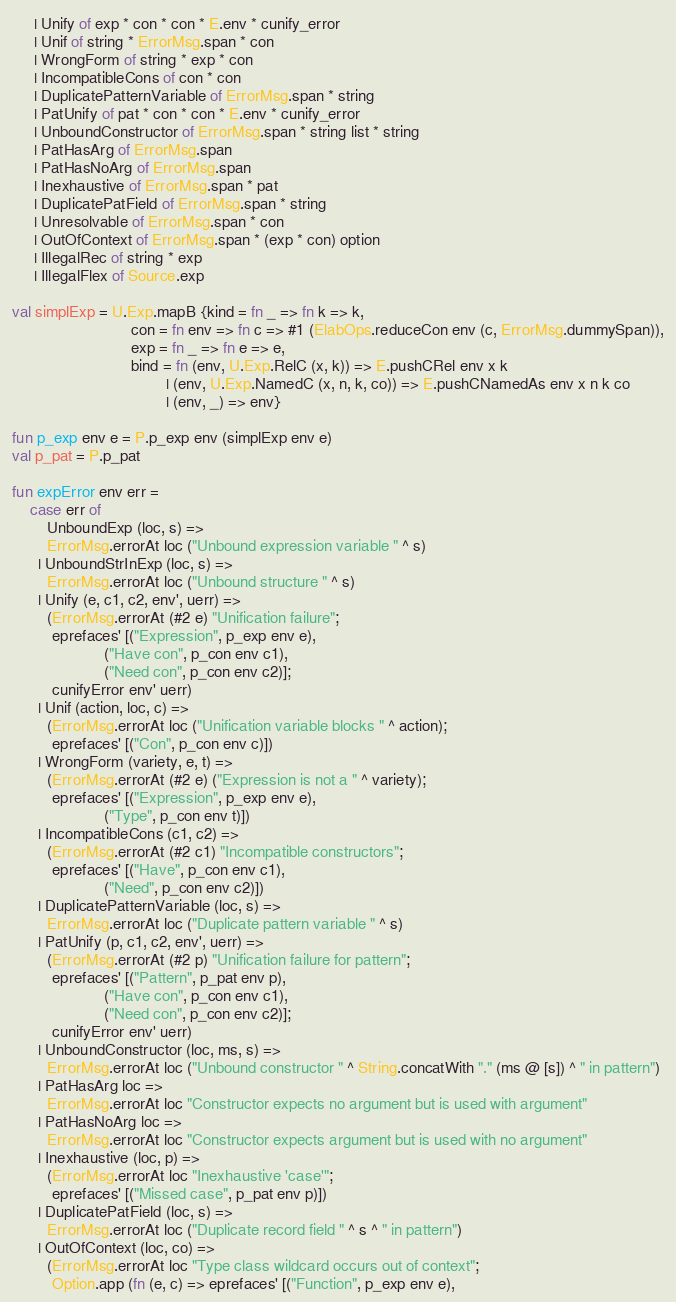<code> <loc_0><loc_0><loc_500><loc_500><_SML_>     | Unify of exp * con * con * E.env * cunify_error
     | Unif of string * ErrorMsg.span * con
     | WrongForm of string * exp * con
     | IncompatibleCons of con * con
     | DuplicatePatternVariable of ErrorMsg.span * string
     | PatUnify of pat * con * con * E.env * cunify_error
     | UnboundConstructor of ErrorMsg.span * string list * string
     | PatHasArg of ErrorMsg.span
     | PatHasNoArg of ErrorMsg.span
     | Inexhaustive of ErrorMsg.span * pat
     | DuplicatePatField of ErrorMsg.span * string
     | Unresolvable of ErrorMsg.span * con
     | OutOfContext of ErrorMsg.span * (exp * con) option
     | IllegalRec of string * exp
     | IllegalFlex of Source.exp

val simplExp = U.Exp.mapB {kind = fn _ => fn k => k,
                           con = fn env => fn c => #1 (ElabOps.reduceCon env (c, ErrorMsg.dummySpan)),
                           exp = fn _ => fn e => e,
                           bind = fn (env, U.Exp.RelC (x, k)) => E.pushCRel env x k
                                   | (env, U.Exp.NamedC (x, n, k, co)) => E.pushCNamedAs env x n k co
                                   | (env, _) => env}

fun p_exp env e = P.p_exp env (simplExp env e)
val p_pat = P.p_pat

fun expError env err =
    case err of
        UnboundExp (loc, s) =>
        ErrorMsg.errorAt loc ("Unbound expression variable " ^ s)
      | UnboundStrInExp (loc, s) =>
        ErrorMsg.errorAt loc ("Unbound structure " ^ s)
      | Unify (e, c1, c2, env', uerr) =>
        (ErrorMsg.errorAt (#2 e) "Unification failure";
         eprefaces' [("Expression", p_exp env e),
                     ("Have con", p_con env c1),
                     ("Need con", p_con env c2)];
         cunifyError env' uerr)
      | Unif (action, loc, c) =>
        (ErrorMsg.errorAt loc ("Unification variable blocks " ^ action);
         eprefaces' [("Con", p_con env c)])
      | WrongForm (variety, e, t) =>
        (ErrorMsg.errorAt (#2 e) ("Expression is not a " ^ variety);
         eprefaces' [("Expression", p_exp env e),
                     ("Type", p_con env t)])
      | IncompatibleCons (c1, c2) =>
        (ErrorMsg.errorAt (#2 c1) "Incompatible constructors";
         eprefaces' [("Have", p_con env c1),
                     ("Need", p_con env c2)])
      | DuplicatePatternVariable (loc, s) =>
        ErrorMsg.errorAt loc ("Duplicate pattern variable " ^ s)
      | PatUnify (p, c1, c2, env', uerr) =>
        (ErrorMsg.errorAt (#2 p) "Unification failure for pattern";
         eprefaces' [("Pattern", p_pat env p),
                     ("Have con", p_con env c1),
                     ("Need con", p_con env c2)];
         cunifyError env' uerr)
      | UnboundConstructor (loc, ms, s) =>
        ErrorMsg.errorAt loc ("Unbound constructor " ^ String.concatWith "." (ms @ [s]) ^ " in pattern")
      | PatHasArg loc =>
        ErrorMsg.errorAt loc "Constructor expects no argument but is used with argument"
      | PatHasNoArg loc =>
        ErrorMsg.errorAt loc "Constructor expects argument but is used with no argument"
      | Inexhaustive (loc, p) =>
        (ErrorMsg.errorAt loc "Inexhaustive 'case'";
         eprefaces' [("Missed case", p_pat env p)])
      | DuplicatePatField (loc, s) =>
        ErrorMsg.errorAt loc ("Duplicate record field " ^ s ^ " in pattern")
      | OutOfContext (loc, co) =>
        (ErrorMsg.errorAt loc "Type class wildcard occurs out of context";
         Option.app (fn (e, c) => eprefaces' [("Function", p_exp env e),</code> 